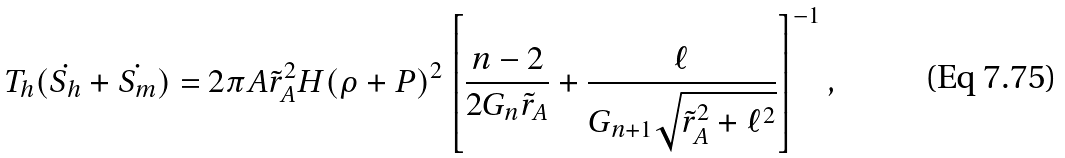Convert formula to latex. <formula><loc_0><loc_0><loc_500><loc_500>T _ { h } ( \dot { S _ { h } } + \dot { S _ { m } } ) = 2 \pi A { \tilde { r } _ { A } } ^ { 2 } H ( \rho + P ) ^ { 2 } \left [ \frac { n - 2 } { 2 G _ { n } \tilde { r } _ { A } } + \frac { \ell } { G _ { n + 1 } \sqrt { { \tilde { r } _ { A } } ^ { 2 } + \ell ^ { 2 } } } \right ] ^ { - 1 } ,</formula> 